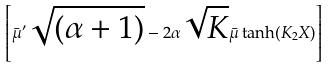Convert formula to latex. <formula><loc_0><loc_0><loc_500><loc_500>\left [ { \bar { \mu } } ^ { \prime } \sqrt { ( \alpha + 1 ) } - 2 \alpha \sqrt { K } \bar { \mu } \tanh ( K _ { 2 } X ) \right ]</formula> 